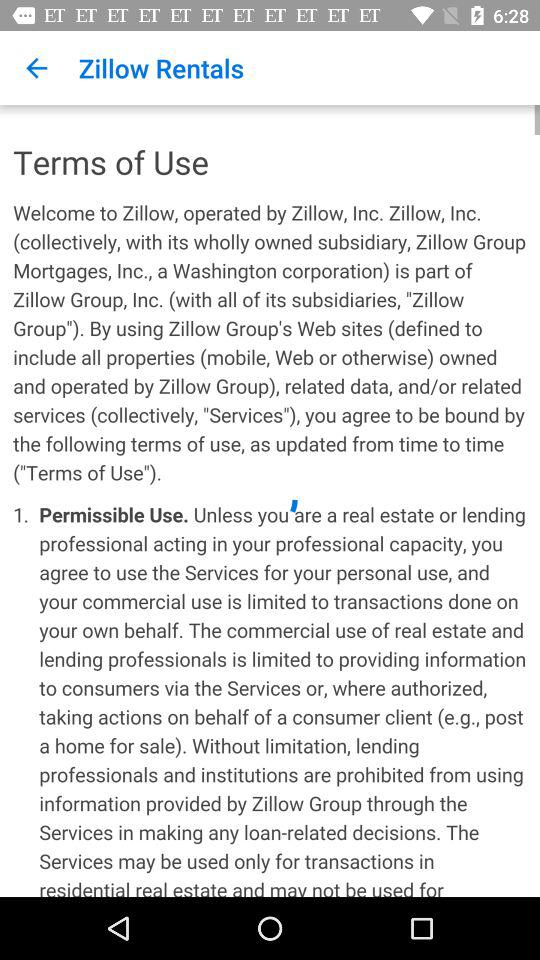What is the name of the application? The name of the application is "Zillow". 